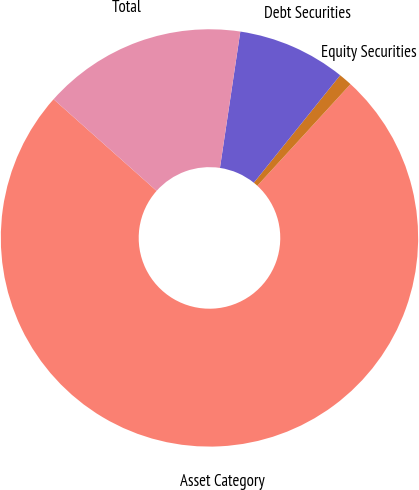<chart> <loc_0><loc_0><loc_500><loc_500><pie_chart><fcel>Asset Category<fcel>Equity Securities<fcel>Debt Securities<fcel>Total<nl><fcel>74.76%<fcel>1.04%<fcel>8.41%<fcel>15.79%<nl></chart> 